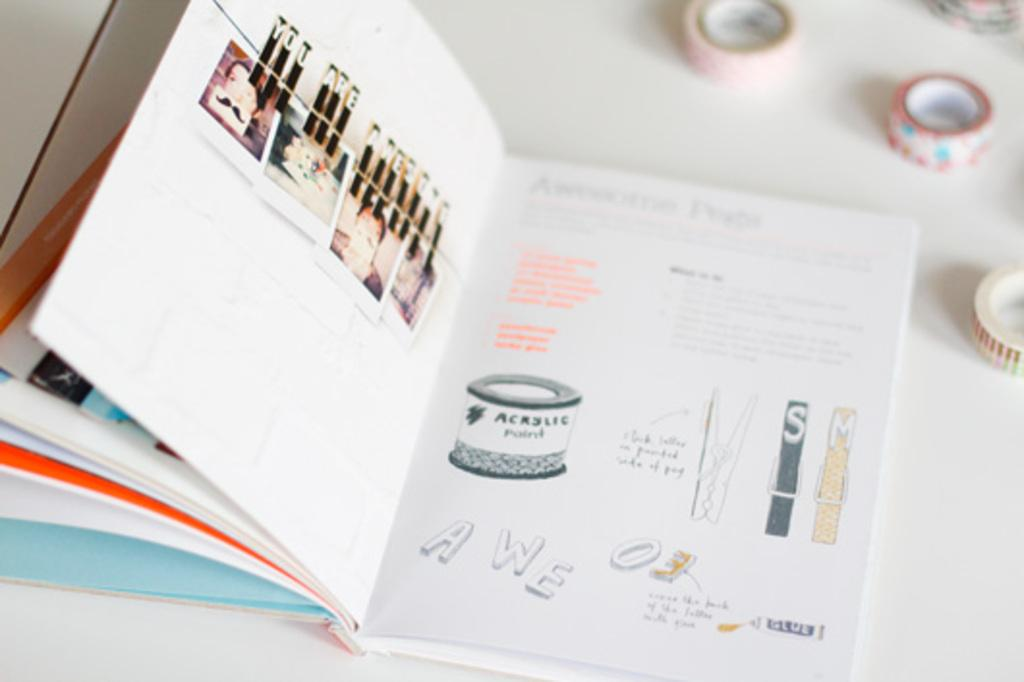Provide a one-sentence caption for the provided image. On the left page the paper clips spell out you are awesome. 